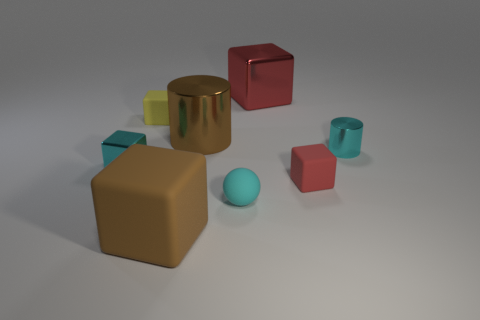How many red cubes must be subtracted to get 1 red cubes? 1 Subtract 2 blocks. How many blocks are left? 3 Subtract all brown cubes. How many cubes are left? 4 Subtract all big matte cubes. How many cubes are left? 4 Subtract all yellow blocks. Subtract all gray balls. How many blocks are left? 4 Add 1 purple balls. How many objects exist? 9 Subtract all blocks. How many objects are left? 3 Add 6 brown metallic cylinders. How many brown metallic cylinders are left? 7 Add 6 purple rubber objects. How many purple rubber objects exist? 6 Subtract 0 blue cylinders. How many objects are left? 8 